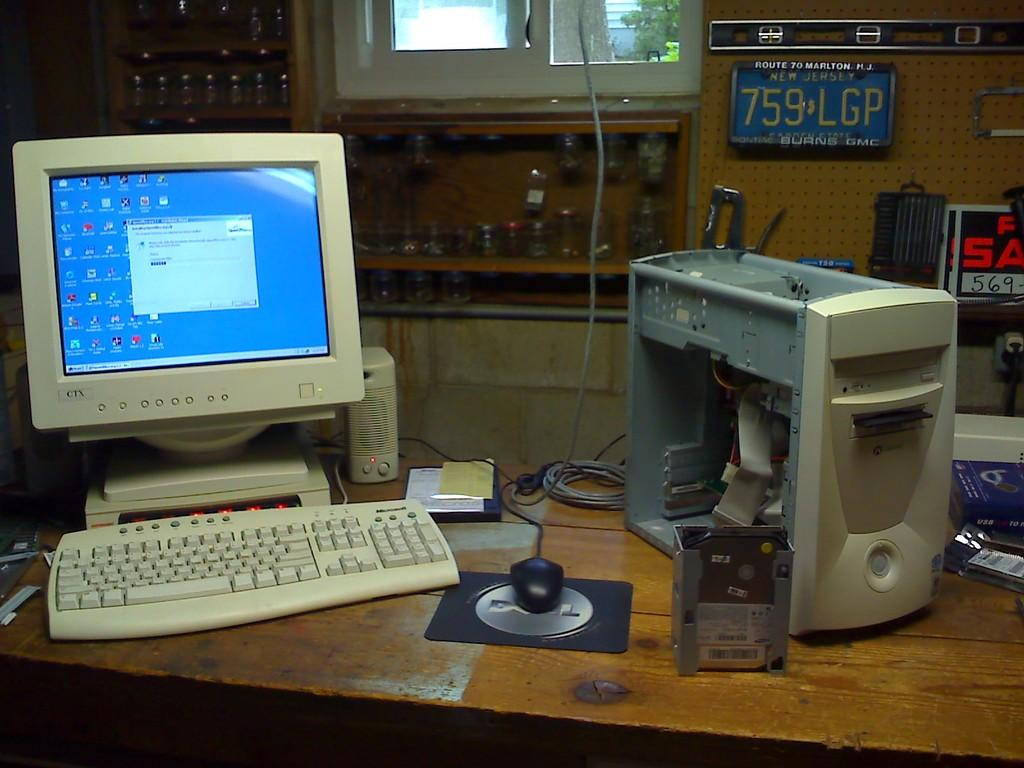Provide a one-sentence caption for the provided image. A CTX monitor is above a keyboard on a desk. 